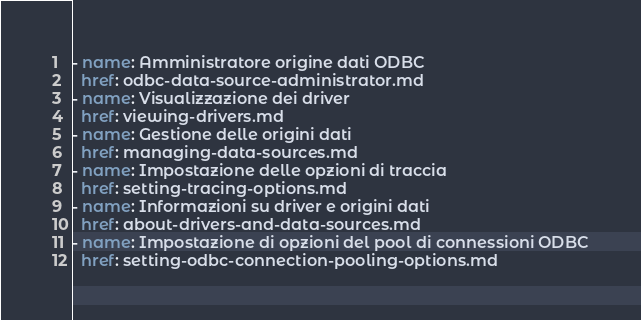<code> <loc_0><loc_0><loc_500><loc_500><_YAML_>- name: Amministratore origine dati ODBC
  href: odbc-data-source-administrator.md
- name: Visualizzazione dei driver
  href: viewing-drivers.md
- name: Gestione delle origini dati
  href: managing-data-sources.md
- name: Impostazione delle opzioni di traccia
  href: setting-tracing-options.md
- name: Informazioni su driver e origini dati
  href: about-drivers-and-data-sources.md
- name: Impostazione di opzioni del pool di connessioni ODBC
  href: setting-odbc-connection-pooling-options.md</code> 